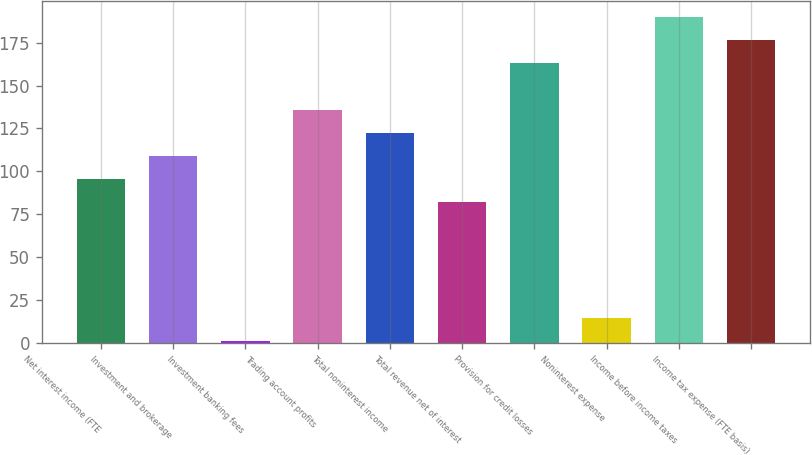Convert chart. <chart><loc_0><loc_0><loc_500><loc_500><bar_chart><fcel>Net interest income (FTE<fcel>Investment and brokerage<fcel>Investment banking fees<fcel>Trading account profits<fcel>Total noninterest income<fcel>Total revenue net of interest<fcel>Provision for credit losses<fcel>Noninterest expense<fcel>Income before income taxes<fcel>Income tax expense (FTE basis)<nl><fcel>95.5<fcel>109<fcel>1<fcel>136<fcel>122.5<fcel>82<fcel>163<fcel>14.5<fcel>190<fcel>176.5<nl></chart> 